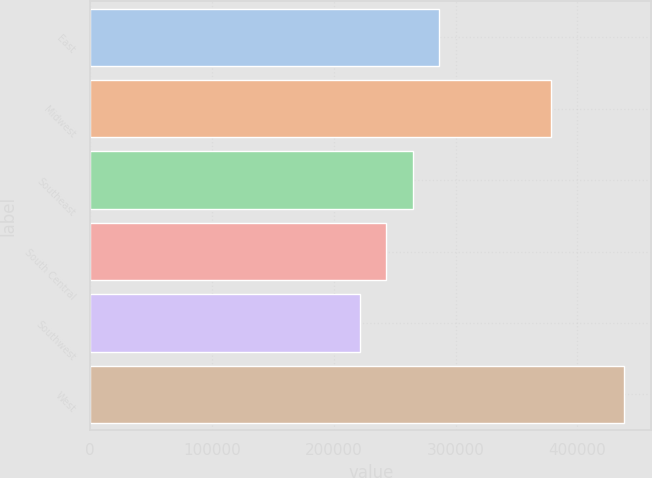Convert chart to OTSL. <chart><loc_0><loc_0><loc_500><loc_500><bar_chart><fcel>East<fcel>Midwest<fcel>Southeast<fcel>South Central<fcel>Southwest<fcel>West<nl><fcel>286490<fcel>377900<fcel>264760<fcel>243030<fcel>221300<fcel>438600<nl></chart> 